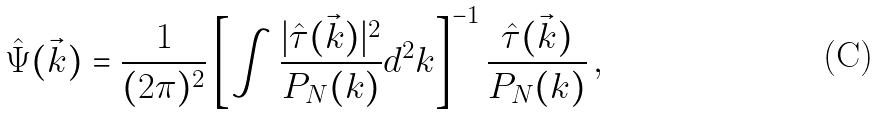<formula> <loc_0><loc_0><loc_500><loc_500>\hat { \Psi } ( \vec { k } ) = \frac { 1 } { ( 2 \pi ) ^ { 2 } } \left [ \int \frac { | \hat { \tau } ( \vec { k } ) | ^ { 2 } } { P _ { N } ( k ) } d ^ { 2 } k \right ] ^ { - 1 } \frac { \hat { \tau } ( \vec { k } ) } { P _ { N } ( k ) } \, ,</formula> 